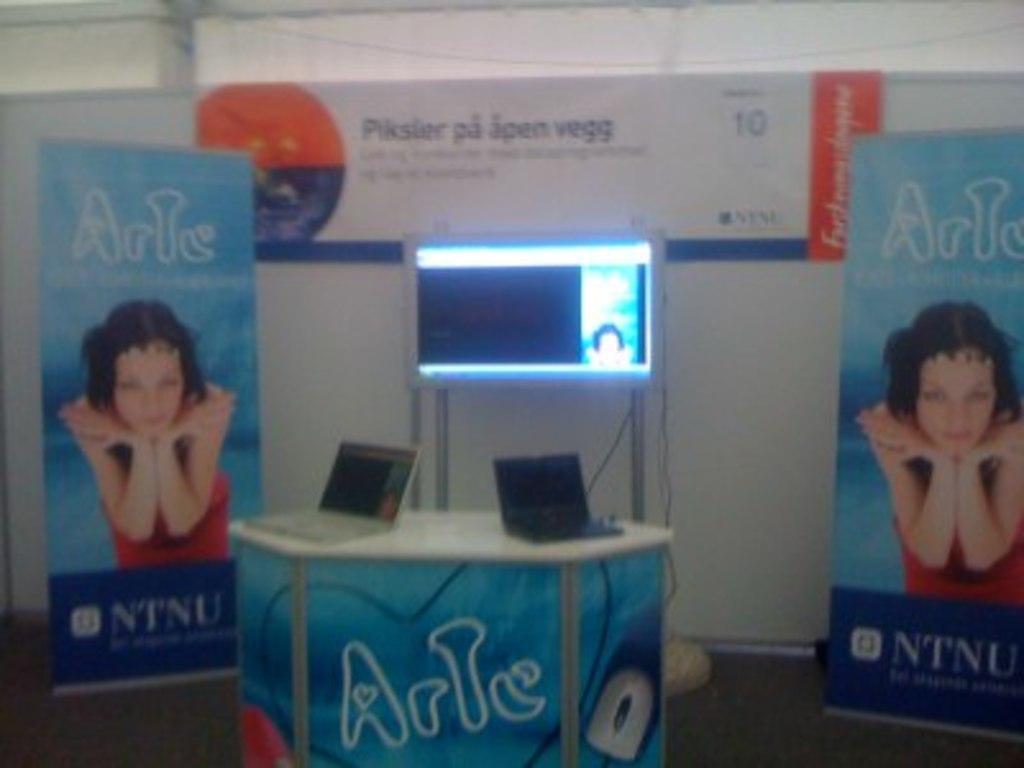How would you summarize this image in a sentence or two? In the foreground of this image, there are two banners, a screen, wall and two laptops on a table. 